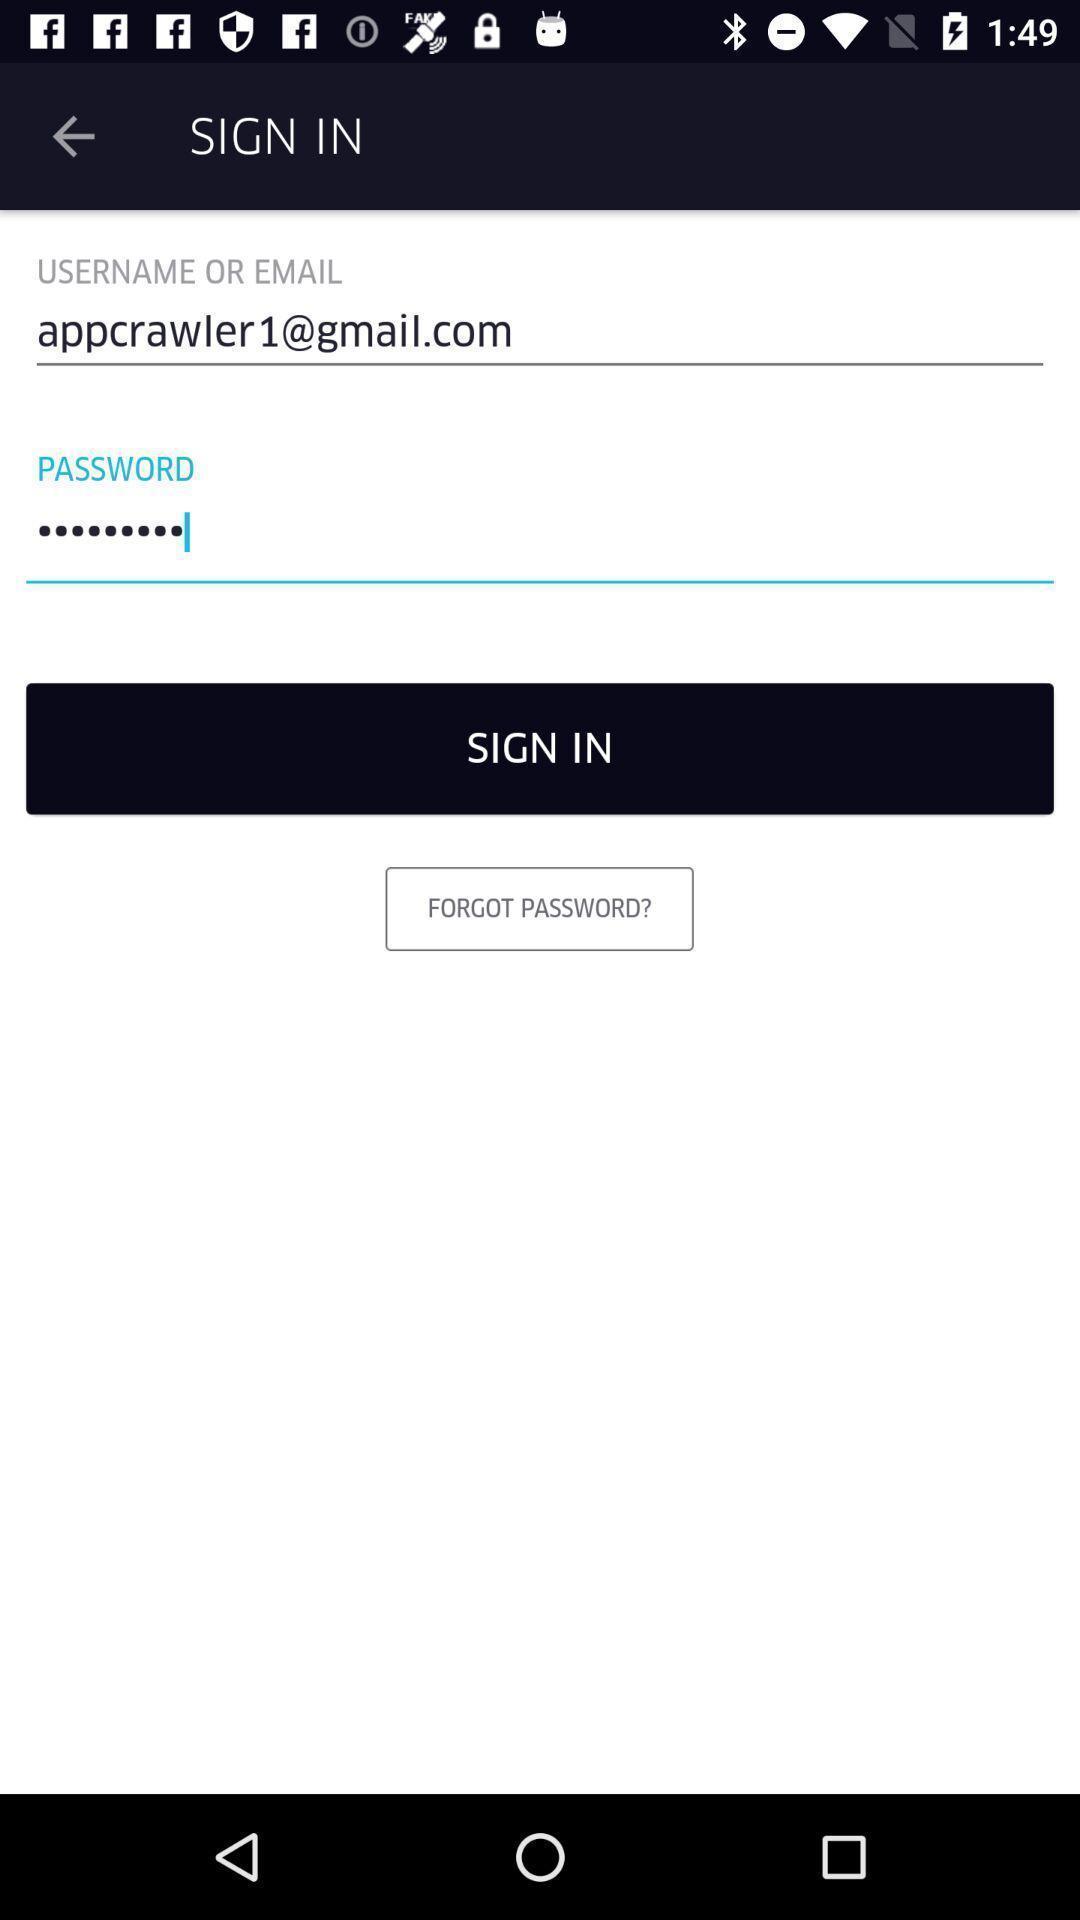Summarize the main components in this picture. Sign in page. 